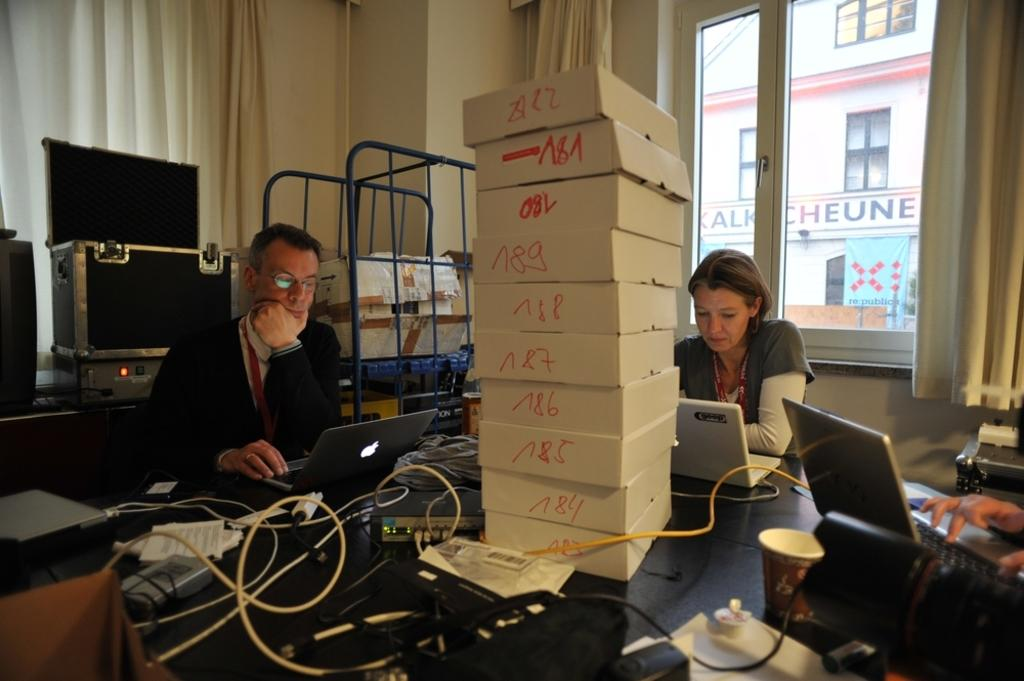<image>
Write a terse but informative summary of the picture. White boxes stacked on top of a table as people are working with top box being "A22". 